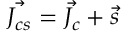Convert formula to latex. <formula><loc_0><loc_0><loc_500><loc_500>\vec { J _ { c s } } = \vec { J _ { c } } + \vec { s }</formula> 